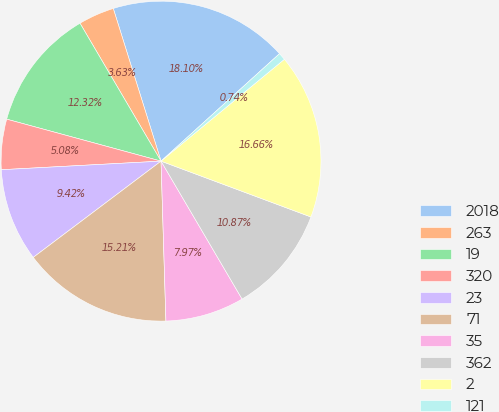<chart> <loc_0><loc_0><loc_500><loc_500><pie_chart><fcel>2018<fcel>263<fcel>19<fcel>320<fcel>23<fcel>71<fcel>35<fcel>362<fcel>2<fcel>121<nl><fcel>18.1%<fcel>3.63%<fcel>12.32%<fcel>5.08%<fcel>9.42%<fcel>15.21%<fcel>7.97%<fcel>10.87%<fcel>16.66%<fcel>0.74%<nl></chart> 